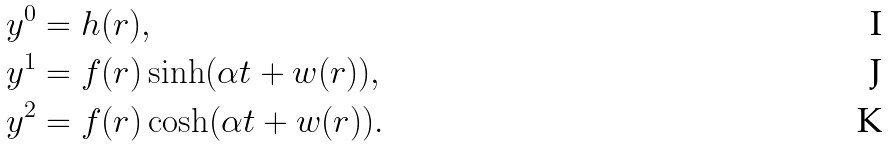<formula> <loc_0><loc_0><loc_500><loc_500>y ^ { 0 } & = h ( r ) , \\ y ^ { 1 } & = f ( r ) \sinh ( \alpha t + w ( r ) ) , \\ y ^ { 2 } & = f ( r ) \cosh ( \alpha t + w ( r ) ) .</formula> 